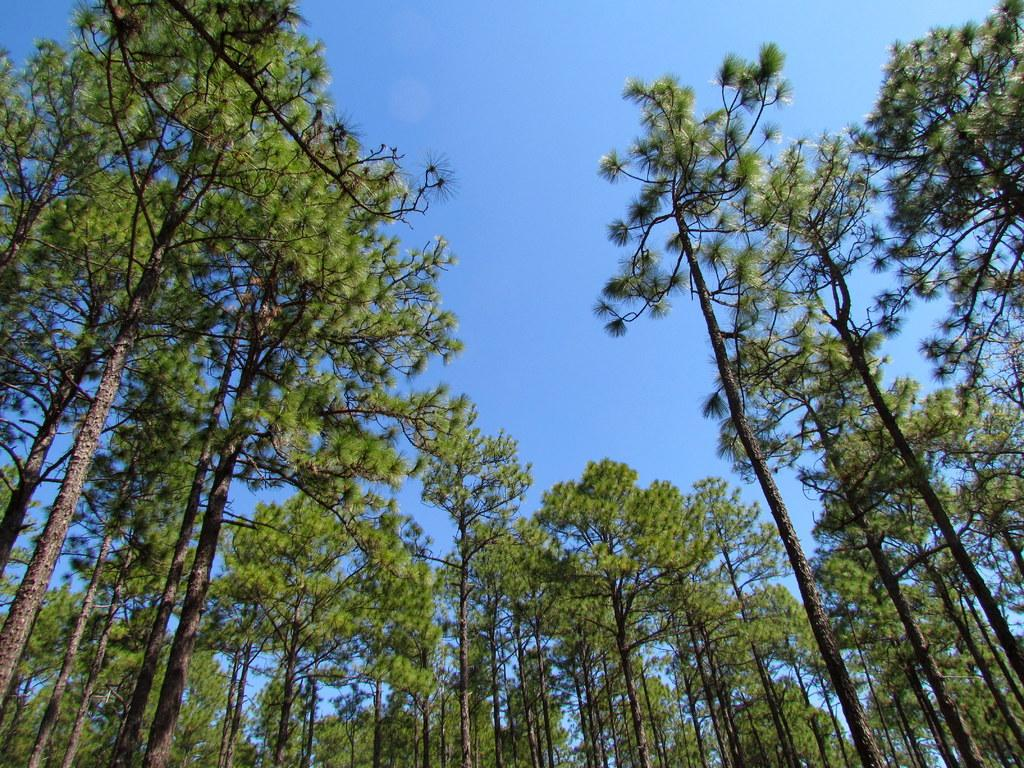What type of vegetation can be seen in the image? There are trees in the image. What part of the natural environment is visible in the image? The sky is visible in the image. What is the name of the ocean that can be seen in the image? There is no ocean present in the image; it only features trees and the sky. How does the image turn into a different scene? The image does not turn into a different scene; it remains the same as described in the facts. 